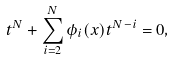<formula> <loc_0><loc_0><loc_500><loc_500>t ^ { N } + \sum _ { i = 2 } ^ { N } \phi _ { i } ( x ) t ^ { N - i } = 0 ,</formula> 